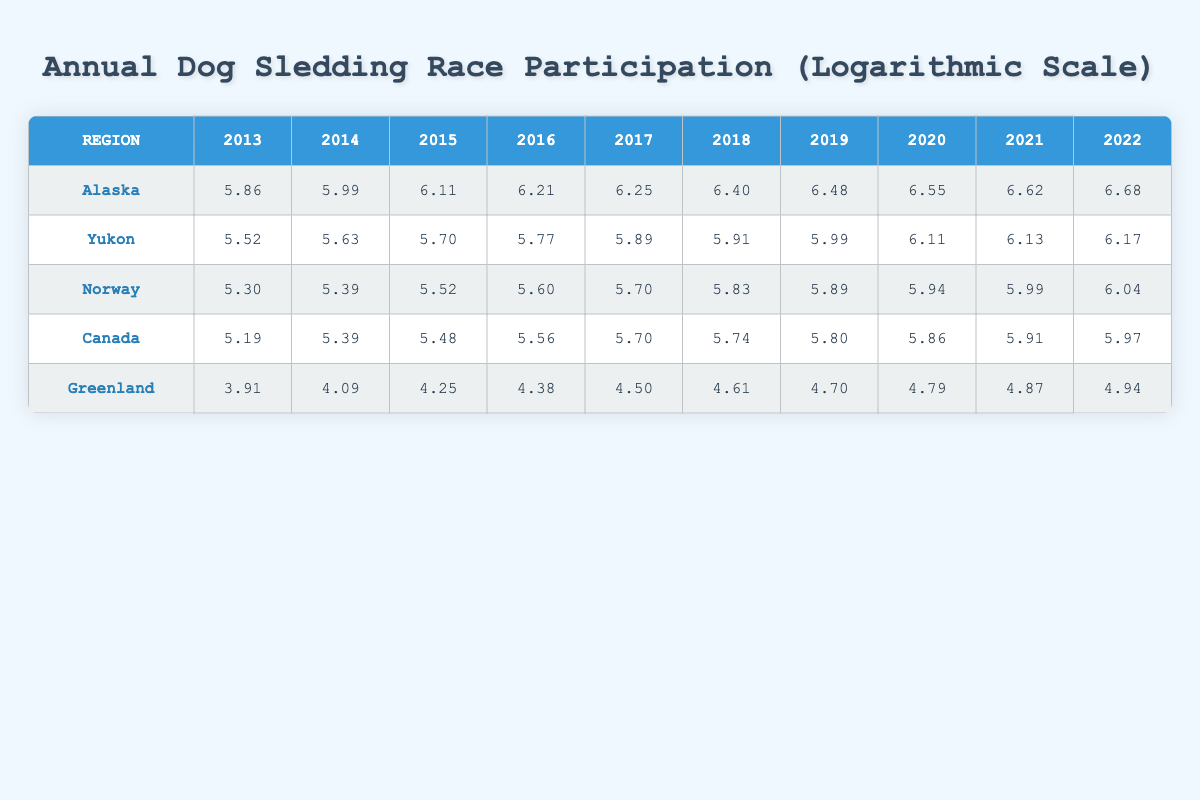What was the participation in dog sledding races in Alaska in 2015? In the row for Alaska, the value for the year 2015 is listed as 6.11.
Answer: 6.11 Which region had the highest participation in dog sledding races in 2020? Comparing the values for 2020 across all regions, Alaska (6.55) has the highest value, followed by Yukon (6.11) and Norway (5.94).
Answer: Alaska What is the difference in participation between 2013 and 2022 for Greenland? The value for Greenland in 2013 is 3.91, and in 2022 it is 4.94. The difference is 4.94 - 3.91 = 1.03.
Answer: 1.03 What is the average participation across all regions in 2021? The values for 2021 are 6.68 (Alaska), 6.13 (Yukon), 5.99 (Norway), 5.91 (Canada), and 4.87 (Greenland). Summing these gives 29.58. Dividing by 5 gives an average of 5.916.
Answer: 5.92 Did Norway ever have a higher participation than Canada during the decade? Yes, in all years from 2015 to 2022, Norway's values are equal to or higher than Canada’s corresponding values. In particular, Norway's 2022 value (6.04) is greater than Canada's (5.97).
Answer: Yes In which year did Yukon see the biggest increase in participation? By examining the annual values for Yukon, the year with the highest increase is 2016 to 2017, which moves from 5.77 to 5.89, an increase of 0.12.
Answer: 2016 to 2017 What was the participation in dog sledding races for Canada in 2014? In the row for Canada, the value for the year 2014 is listed as 5.39.
Answer: 5.39 What trend can be observed in participation data from 2013 to 2022 for all regions? Looking at the table, there is a consistent upward trend in participation for all regions, showing increases each year. This indicates a growing interest in dog sledding races over the decade.
Answer: Upward trend 